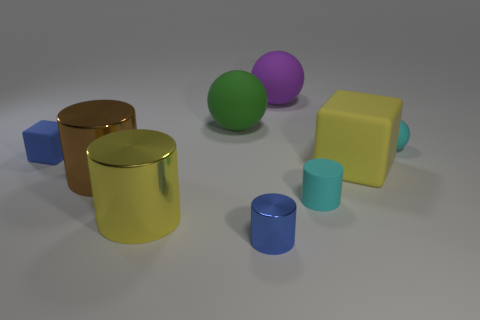Subtract all yellow cylinders. How many cylinders are left? 3 Subtract all green cylinders. Subtract all yellow spheres. How many cylinders are left? 4 Subtract all blocks. How many objects are left? 7 Subtract all small red shiny things. Subtract all spheres. How many objects are left? 6 Add 3 small things. How many small things are left? 7 Add 1 blue things. How many blue things exist? 3 Subtract 0 red cylinders. How many objects are left? 9 